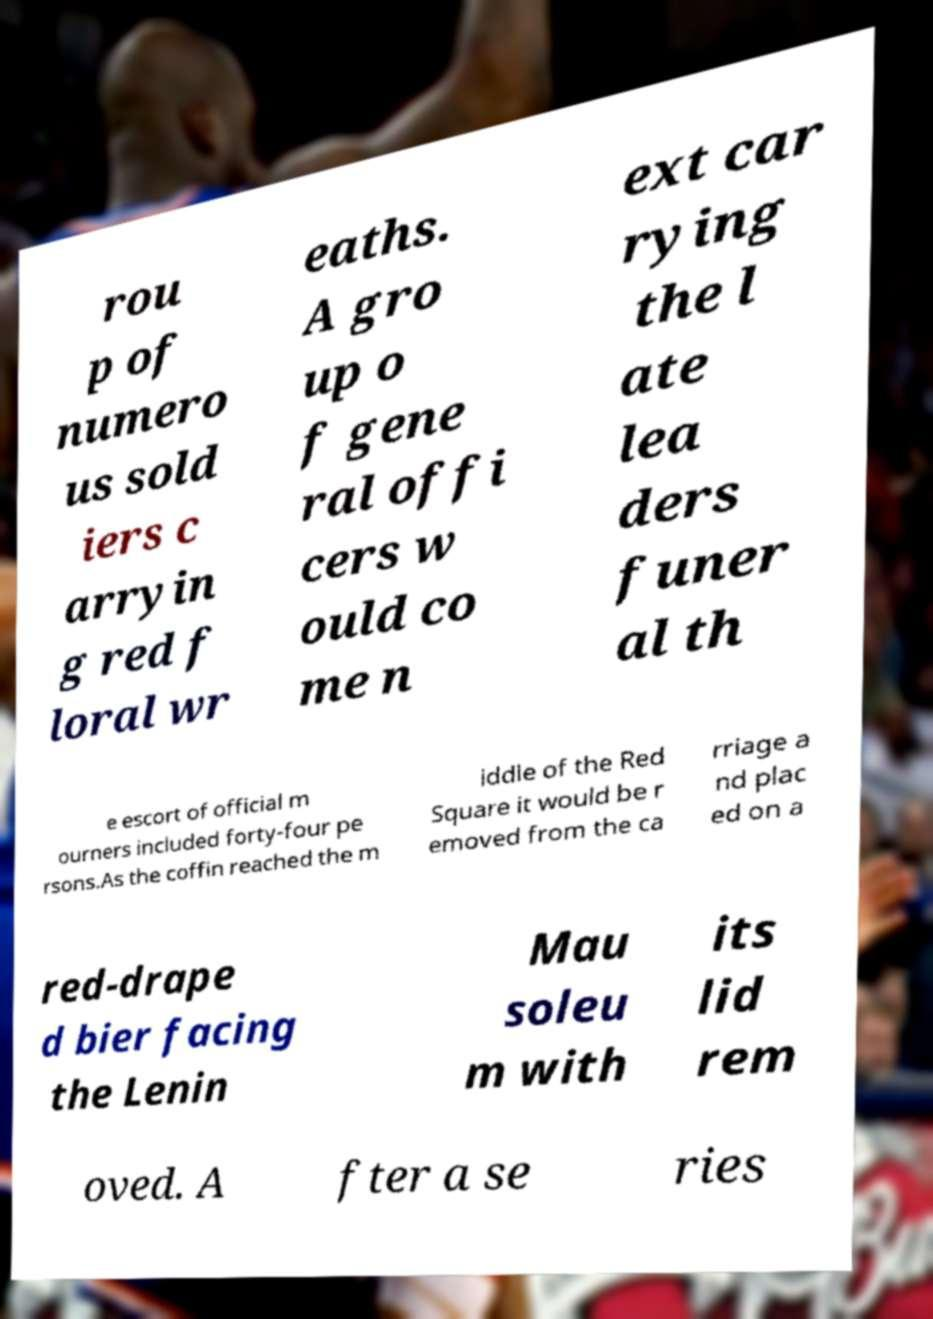What messages or text are displayed in this image? I need them in a readable, typed format. rou p of numero us sold iers c arryin g red f loral wr eaths. A gro up o f gene ral offi cers w ould co me n ext car rying the l ate lea ders funer al th e escort of official m ourners included forty-four pe rsons.As the coffin reached the m iddle of the Red Square it would be r emoved from the ca rriage a nd plac ed on a red-drape d bier facing the Lenin Mau soleu m with its lid rem oved. A fter a se ries 